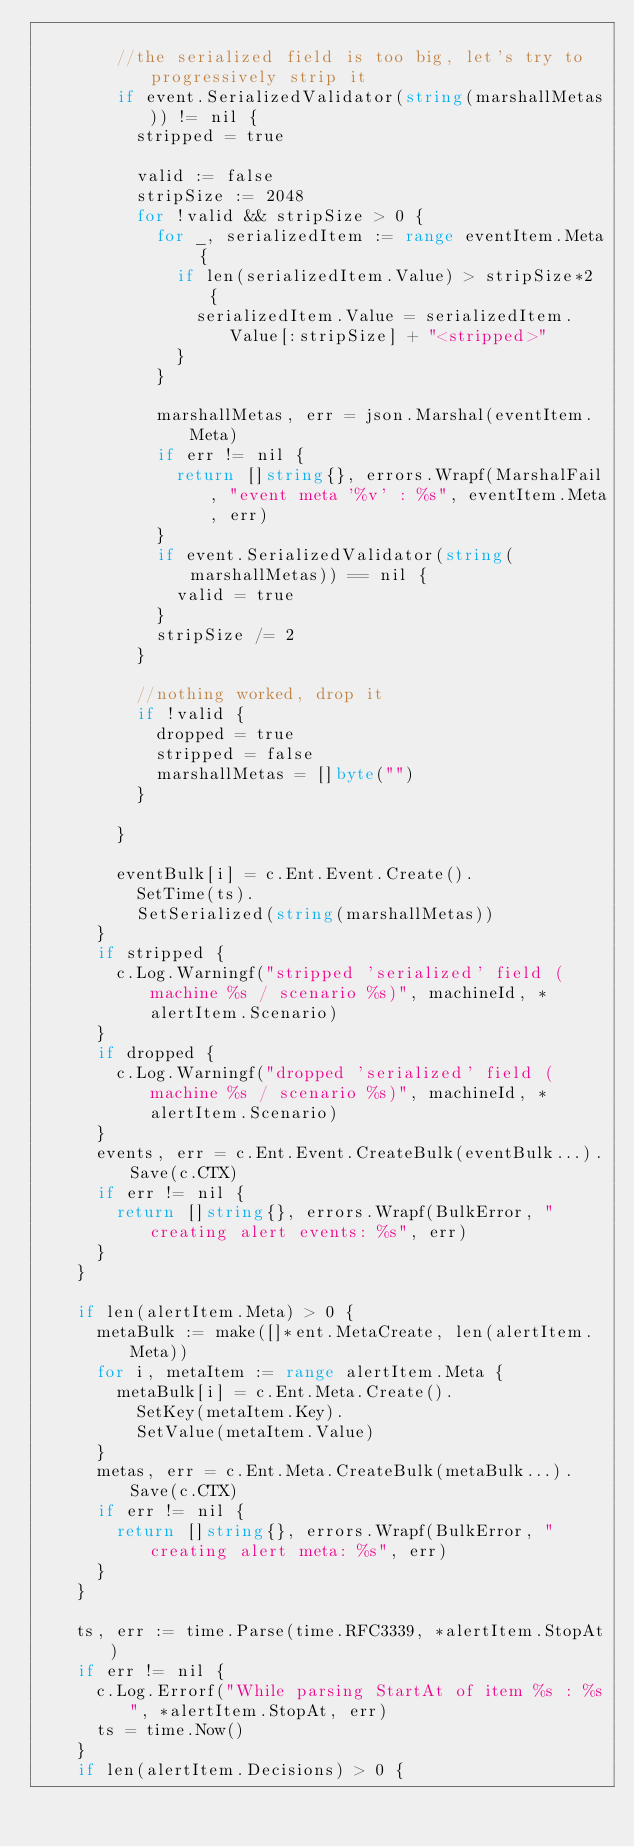<code> <loc_0><loc_0><loc_500><loc_500><_Go_>
				//the serialized field is too big, let's try to progressively strip it
				if event.SerializedValidator(string(marshallMetas)) != nil {
					stripped = true

					valid := false
					stripSize := 2048
					for !valid && stripSize > 0 {
						for _, serializedItem := range eventItem.Meta {
							if len(serializedItem.Value) > stripSize*2 {
								serializedItem.Value = serializedItem.Value[:stripSize] + "<stripped>"
							}
						}

						marshallMetas, err = json.Marshal(eventItem.Meta)
						if err != nil {
							return []string{}, errors.Wrapf(MarshalFail, "event meta '%v' : %s", eventItem.Meta, err)
						}
						if event.SerializedValidator(string(marshallMetas)) == nil {
							valid = true
						}
						stripSize /= 2
					}

					//nothing worked, drop it
					if !valid {
						dropped = true
						stripped = false
						marshallMetas = []byte("")
					}

				}

				eventBulk[i] = c.Ent.Event.Create().
					SetTime(ts).
					SetSerialized(string(marshallMetas))
			}
			if stripped {
				c.Log.Warningf("stripped 'serialized' field (machine %s / scenario %s)", machineId, *alertItem.Scenario)
			}
			if dropped {
				c.Log.Warningf("dropped 'serialized' field (machine %s / scenario %s)", machineId, *alertItem.Scenario)
			}
			events, err = c.Ent.Event.CreateBulk(eventBulk...).Save(c.CTX)
			if err != nil {
				return []string{}, errors.Wrapf(BulkError, "creating alert events: %s", err)
			}
		}

		if len(alertItem.Meta) > 0 {
			metaBulk := make([]*ent.MetaCreate, len(alertItem.Meta))
			for i, metaItem := range alertItem.Meta {
				metaBulk[i] = c.Ent.Meta.Create().
					SetKey(metaItem.Key).
					SetValue(metaItem.Value)
			}
			metas, err = c.Ent.Meta.CreateBulk(metaBulk...).Save(c.CTX)
			if err != nil {
				return []string{}, errors.Wrapf(BulkError, "creating alert meta: %s", err)
			}
		}

		ts, err := time.Parse(time.RFC3339, *alertItem.StopAt)
		if err != nil {
			c.Log.Errorf("While parsing StartAt of item %s : %s", *alertItem.StopAt, err)
			ts = time.Now()
		}
		if len(alertItem.Decisions) > 0 {</code> 